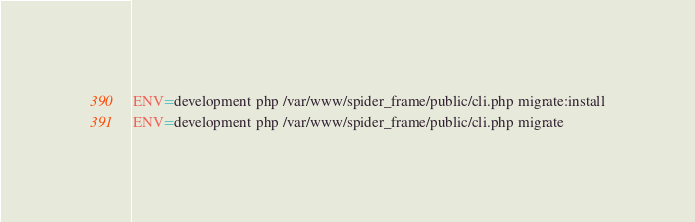Convert code to text. <code><loc_0><loc_0><loc_500><loc_500><_Bash_>
ENV=development php /var/www/spider_frame/public/cli.php migrate:install
ENV=development php /var/www/spider_frame/public/cli.php migrate
</code> 